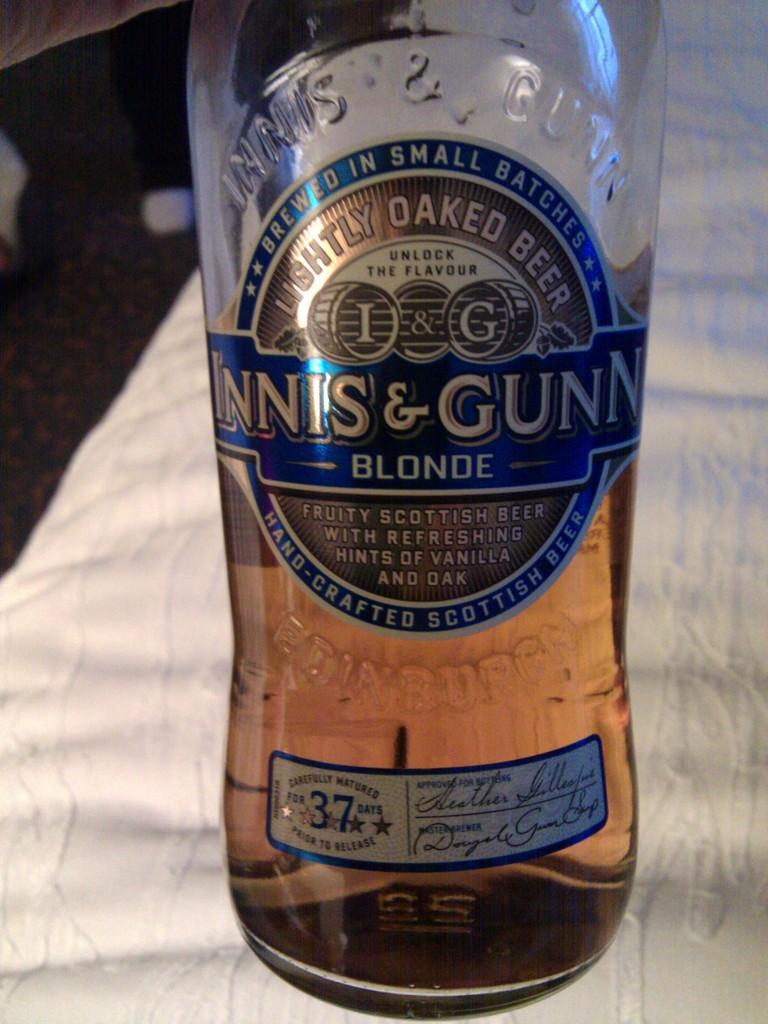Provide a one-sentence caption for the provided image. A half empty bottle of beer from Scotland. 